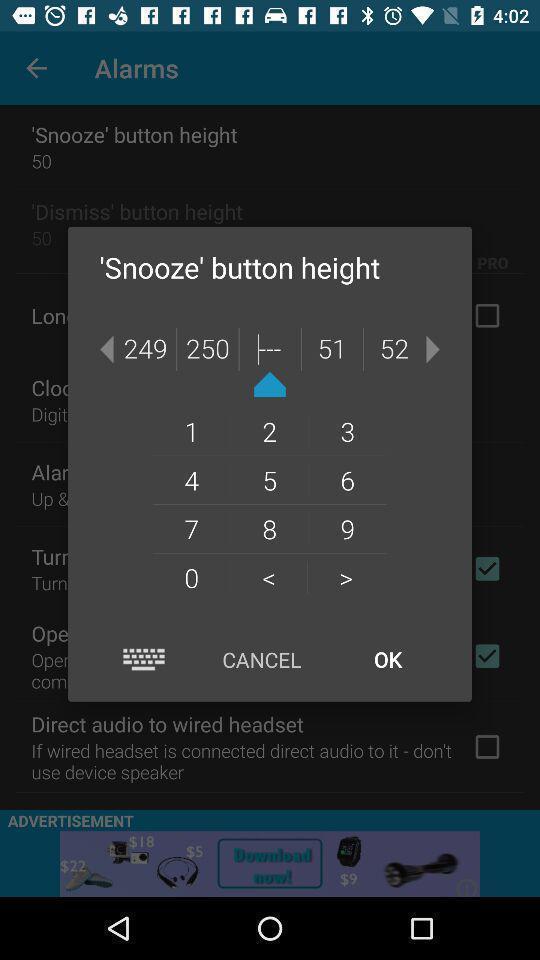Provide a detailed account of this screenshot. Pop-up showing reminder to set. 